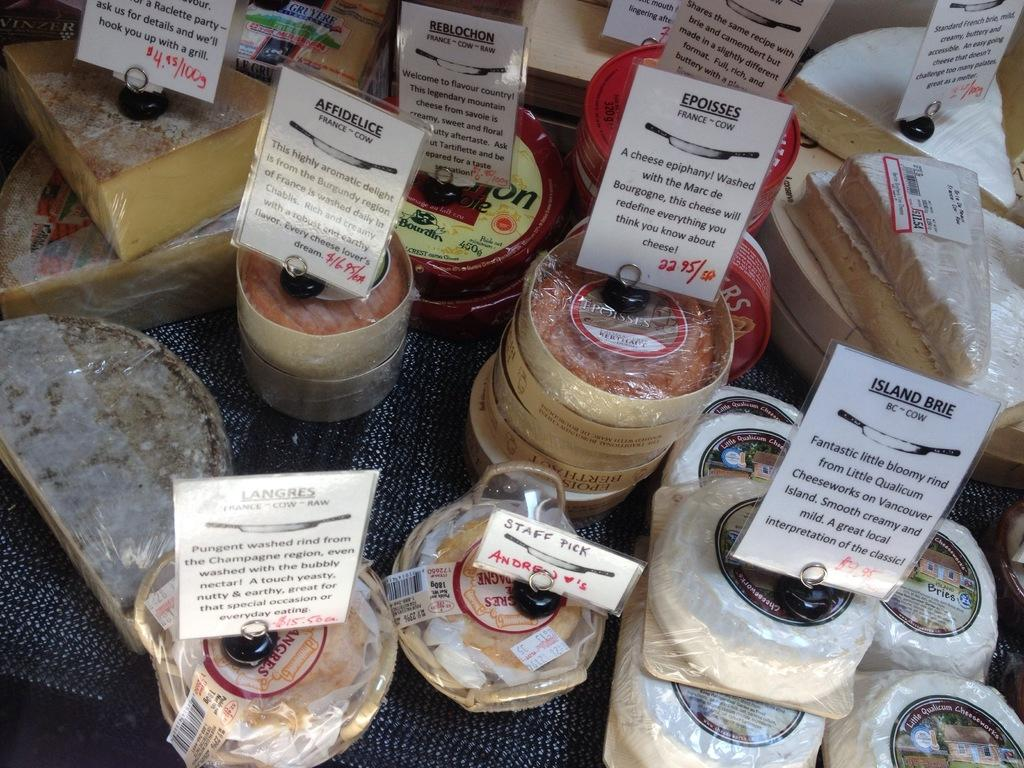What type of furniture is present in the image? There is a table in the image. What is placed on the table? There are posters on the table. What can be seen on the posters? There is writing on the posters. Can you see a dog interacting with the posters on the table in the image? There is no dog present in the image, and therefore no interaction with the posters can be observed. 